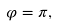<formula> <loc_0><loc_0><loc_500><loc_500>\varphi = \pi ,</formula> 